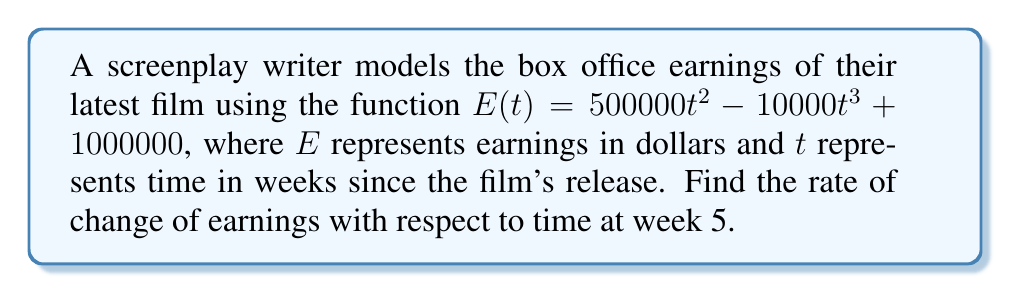Help me with this question. To find the rate of change of earnings with respect to time at week 5, we need to follow these steps:

1. Find the derivative of the earnings function $E(t)$.
2. Evaluate the derivative at $t = 5$.

Step 1: Finding the derivative of $E(t)$

Given: $E(t) = 500000t^2 - 10000t^3 + 1000000$

Using the power rule and constant rule of differentiation:

$$\frac{d}{dt}[500000t^2] = 1000000t$$
$$\frac{d}{dt}[-10000t^3] = -30000t^2$$
$$\frac{d}{dt}[1000000] = 0$$

Combining these terms, we get:

$$E'(t) = 1000000t - 30000t^2$$

Step 2: Evaluating the derivative at $t = 5$

Substitute $t = 5$ into $E'(t)$:

$$E'(5) = 1000000(5) - 30000(5^2)$$
$$E'(5) = 5000000 - 750000$$
$$E'(5) = 4250000$$

Therefore, the rate of change of earnings with respect to time at week 5 is $4,250,000 dollars per week.
Answer: $4,250,000 dollars per week 